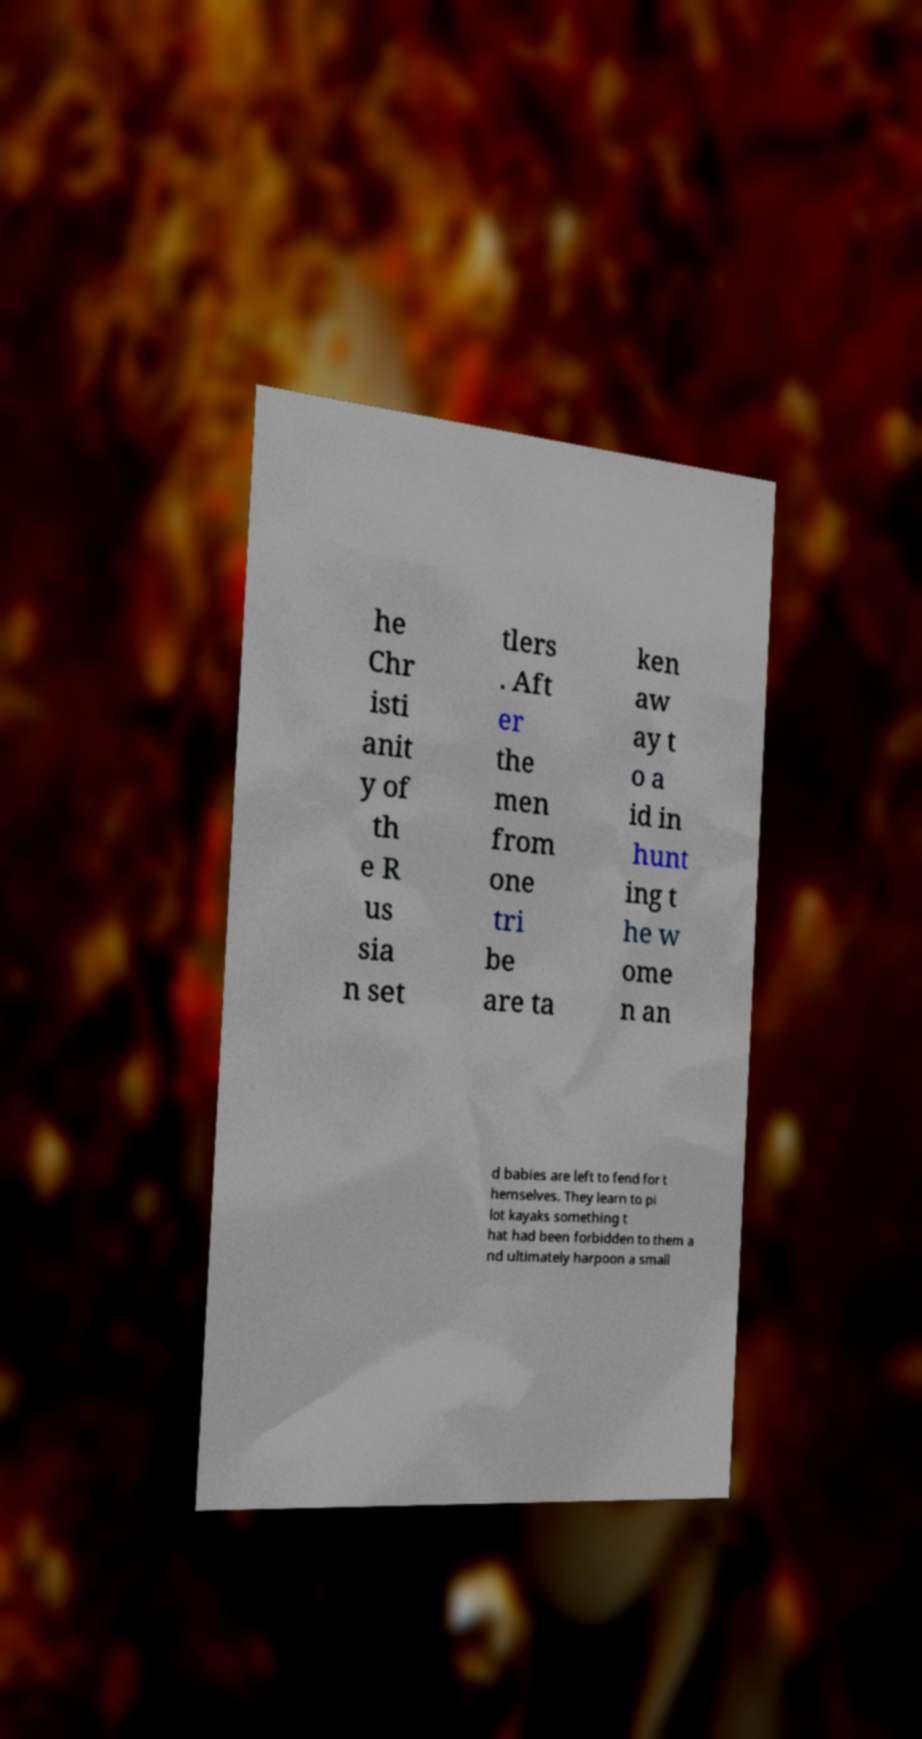I need the written content from this picture converted into text. Can you do that? he Chr isti anit y of th e R us sia n set tlers . Aft er the men from one tri be are ta ken aw ay t o a id in hunt ing t he w ome n an d babies are left to fend for t hemselves. They learn to pi lot kayaks something t hat had been forbidden to them a nd ultimately harpoon a small 